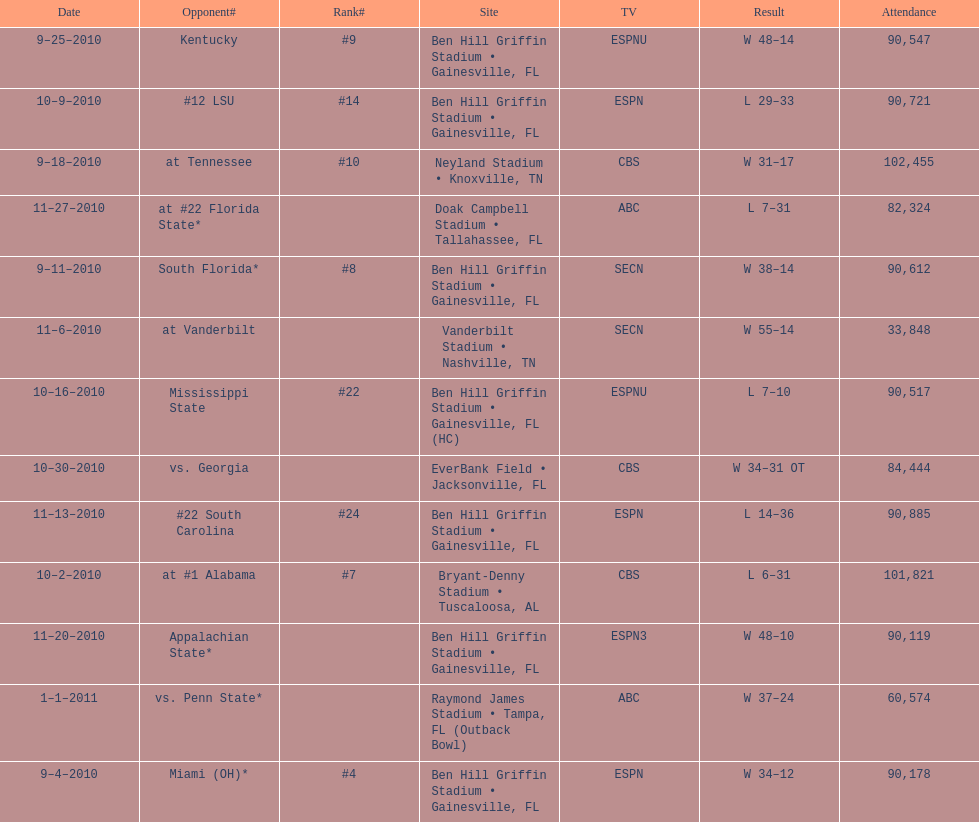What was the difference between the two scores of the last game? 13 points. 